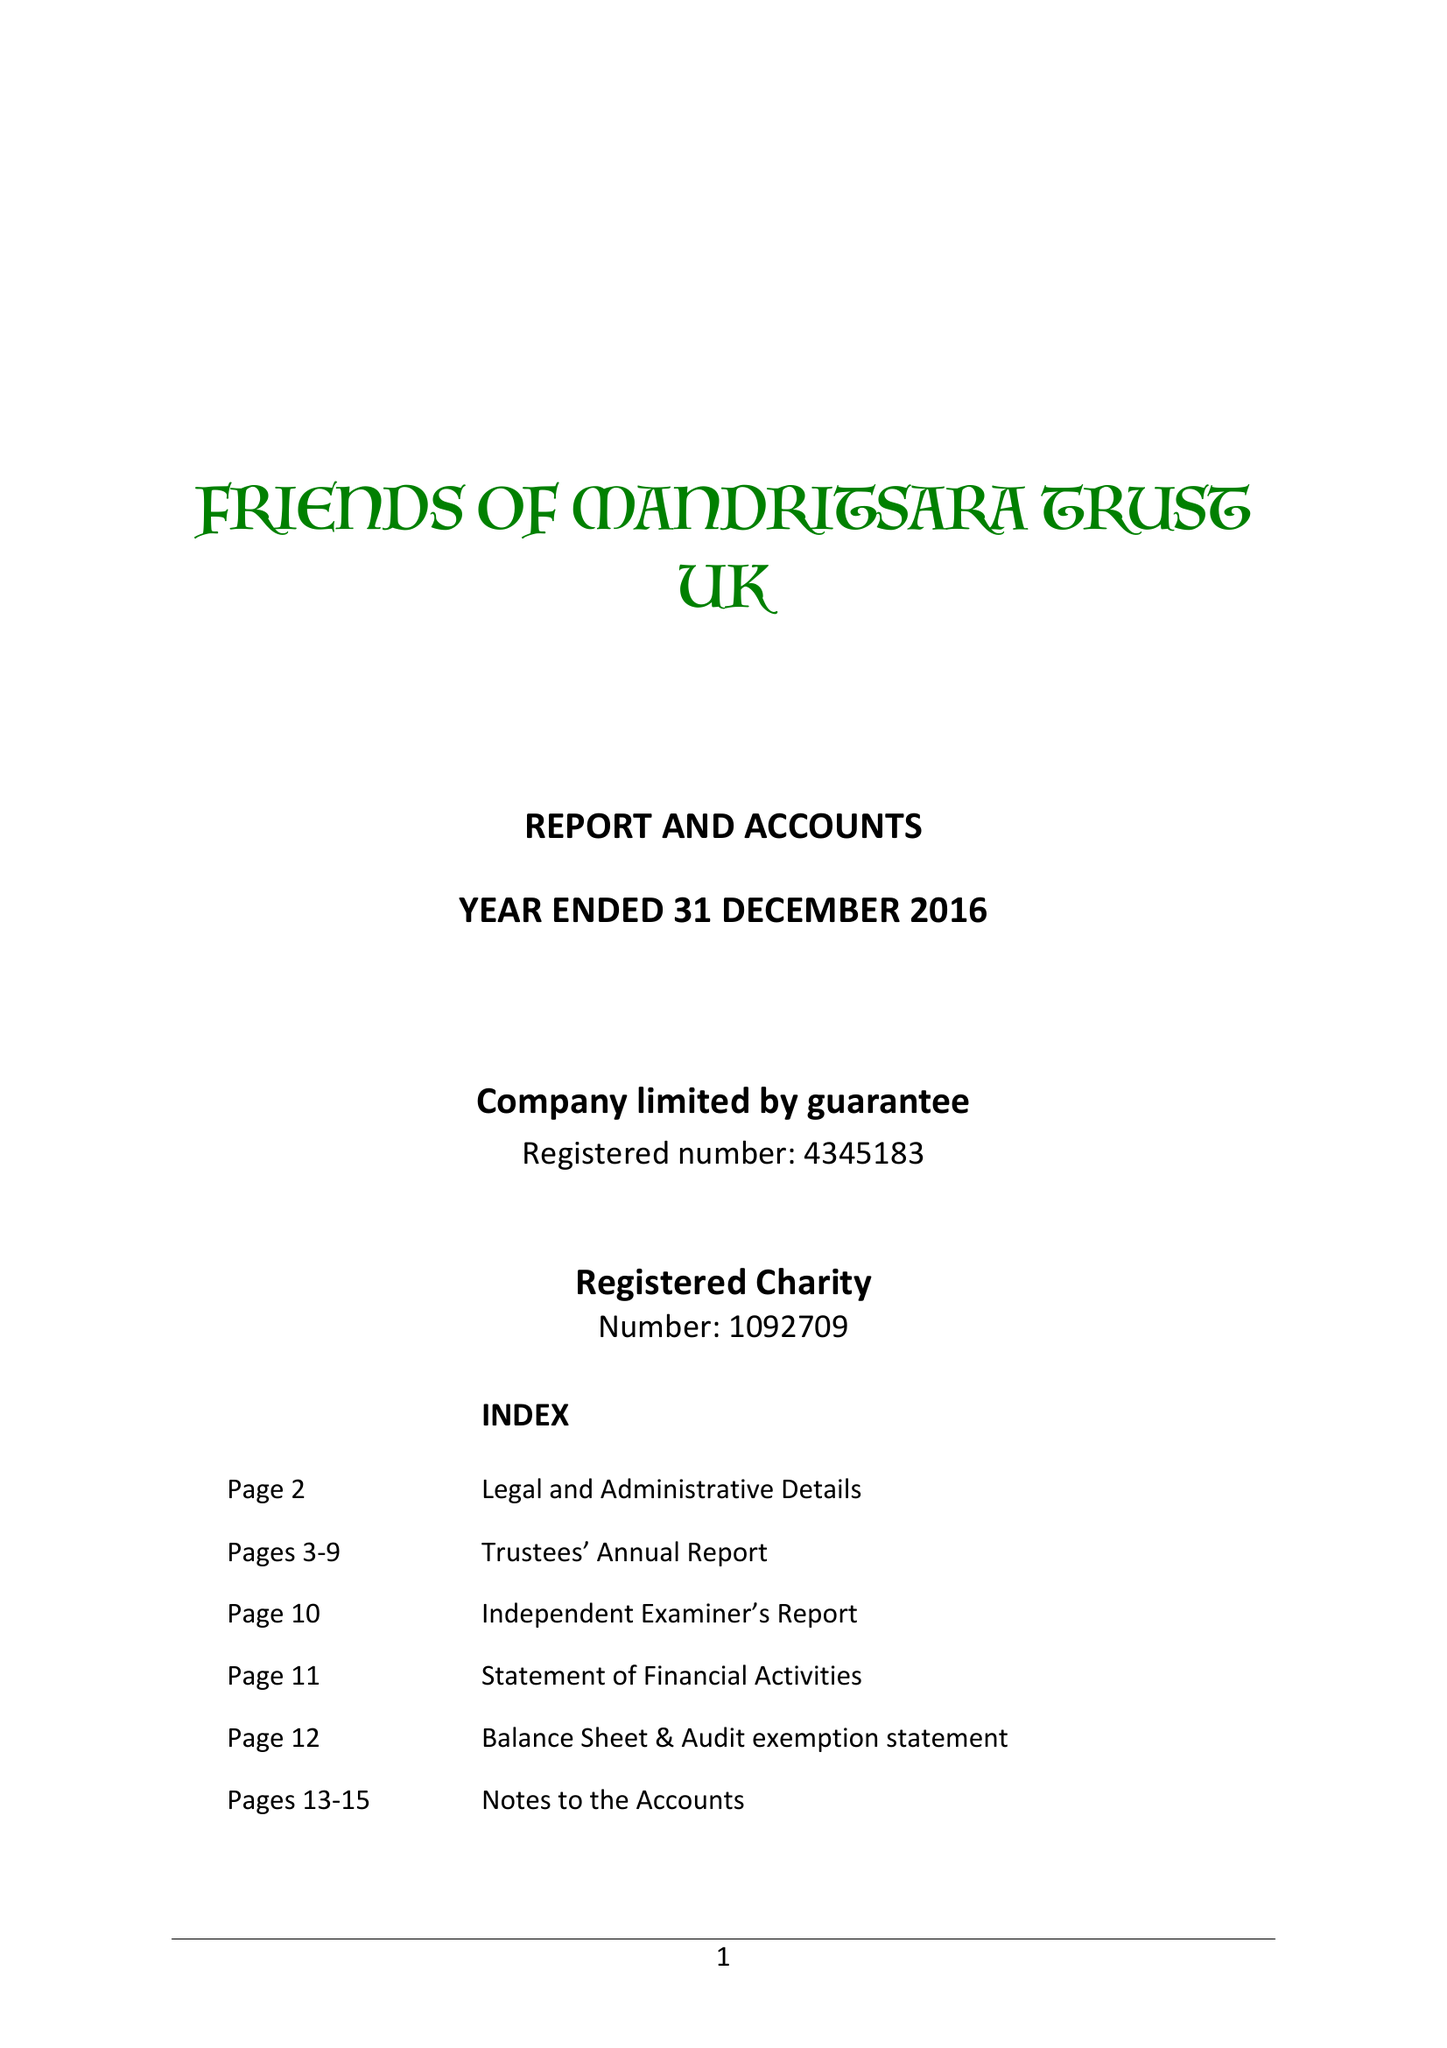What is the value for the spending_annually_in_british_pounds?
Answer the question using a single word or phrase. 245488.00 